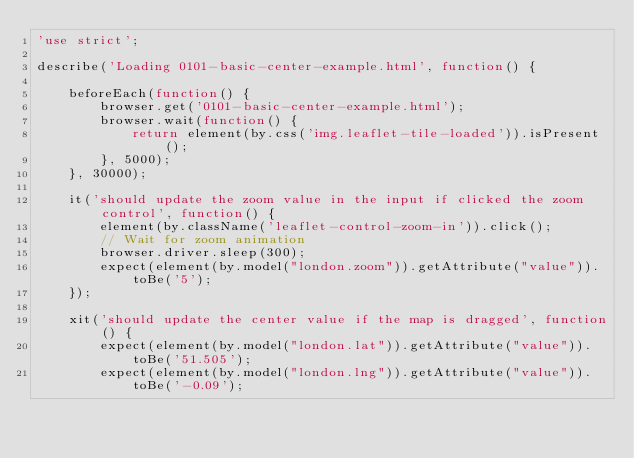<code> <loc_0><loc_0><loc_500><loc_500><_JavaScript_>'use strict';

describe('Loading 0101-basic-center-example.html', function() {

    beforeEach(function() {
        browser.get('0101-basic-center-example.html');
        browser.wait(function() {
            return element(by.css('img.leaflet-tile-loaded')).isPresent();
        }, 5000);
    }, 30000);

    it('should update the zoom value in the input if clicked the zoom control', function() {
        element(by.className('leaflet-control-zoom-in')).click();
        // Wait for zoom animation
        browser.driver.sleep(300);
        expect(element(by.model("london.zoom")).getAttribute("value")).toBe('5');
    });

    xit('should update the center value if the map is dragged', function() {
        expect(element(by.model("london.lat")).getAttribute("value")).toBe('51.505');
        expect(element(by.model("london.lng")).getAttribute("value")).toBe('-0.09');</code> 